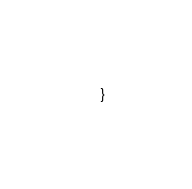Convert code to text. <code><loc_0><loc_0><loc_500><loc_500><_TypeScript_>}
</code> 